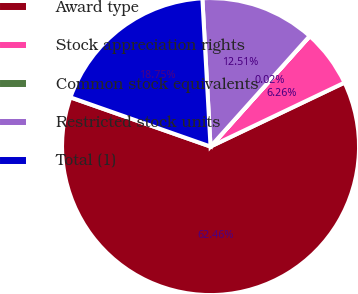Convert chart. <chart><loc_0><loc_0><loc_500><loc_500><pie_chart><fcel>Award type<fcel>Stock appreciation rights<fcel>Common stock equivalents<fcel>Restricted stock units<fcel>Total (1)<nl><fcel>62.47%<fcel>6.26%<fcel>0.02%<fcel>12.51%<fcel>18.75%<nl></chart> 